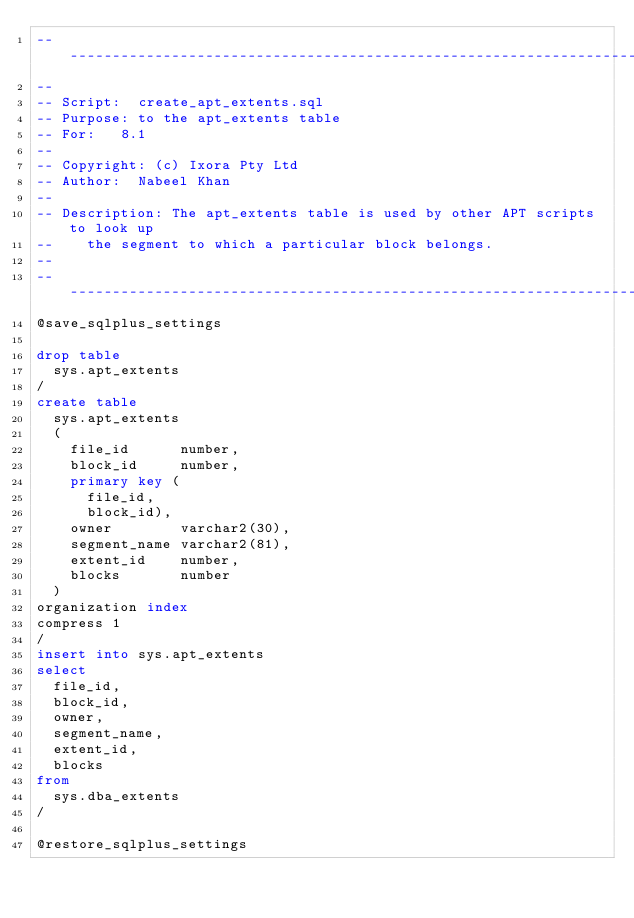Convert code to text. <code><loc_0><loc_0><loc_500><loc_500><_SQL_>-------------------------------------------------------------------------------
--
-- Script:	create_apt_extents.sql
-- Purpose:	to the apt_extents table
-- For:		8.1
--
-- Copyright:	(c) Ixora Pty Ltd
-- Author:	Nabeel Khan
--
-- Description: The apt_extents table is used by other APT scripts to look up
--		the segment to which a particular block belongs.
--
-------------------------------------------------------------------------------
@save_sqlplus_settings

drop table
  sys.apt_extents
/
create table
  sys.apt_extents
  (
    file_id      number,
    block_id     number,
    primary key (
      file_id,
      block_id),
    owner        varchar2(30),
    segment_name varchar2(81),
    extent_id    number,
    blocks       number
  )
organization index
compress 1
/
insert into sys.apt_extents
select
  file_id,
  block_id,
  owner,
  segment_name,
  extent_id,
  blocks
from
  sys.dba_extents
/

@restore_sqlplus_settings
</code> 